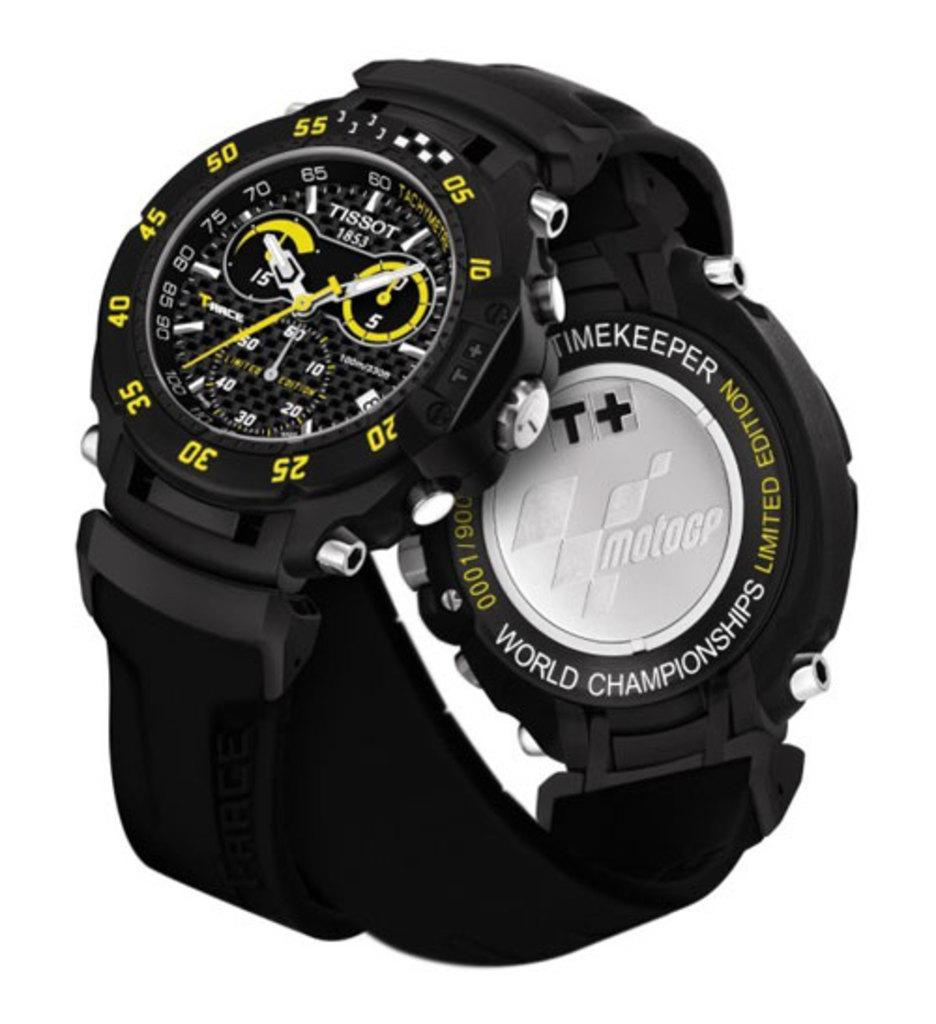<image>
Offer a succinct explanation of the picture presented. A limited edition black watch with yellow features against a white background. 